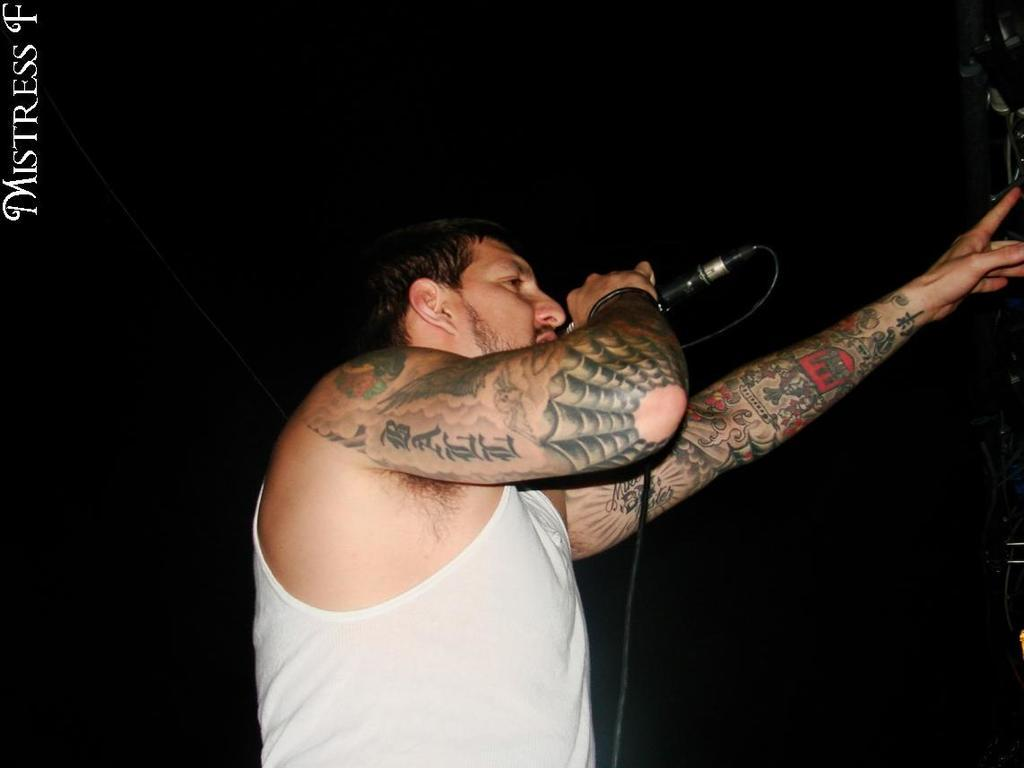What is the main subject of the image? The main subject of the image is a man. What is the man wearing? The man is wearing a white color banian. What is the man's posture in the image? The man is standing. What is the man holding in the image? The man is holding a mic. What is the man doing in the image? The man is singing. What is the color of the background in the image? The background of the image is black. What type of harmony can be heard in the image? There is no sound present in the image, so it is not possible to determine the type of harmony. 